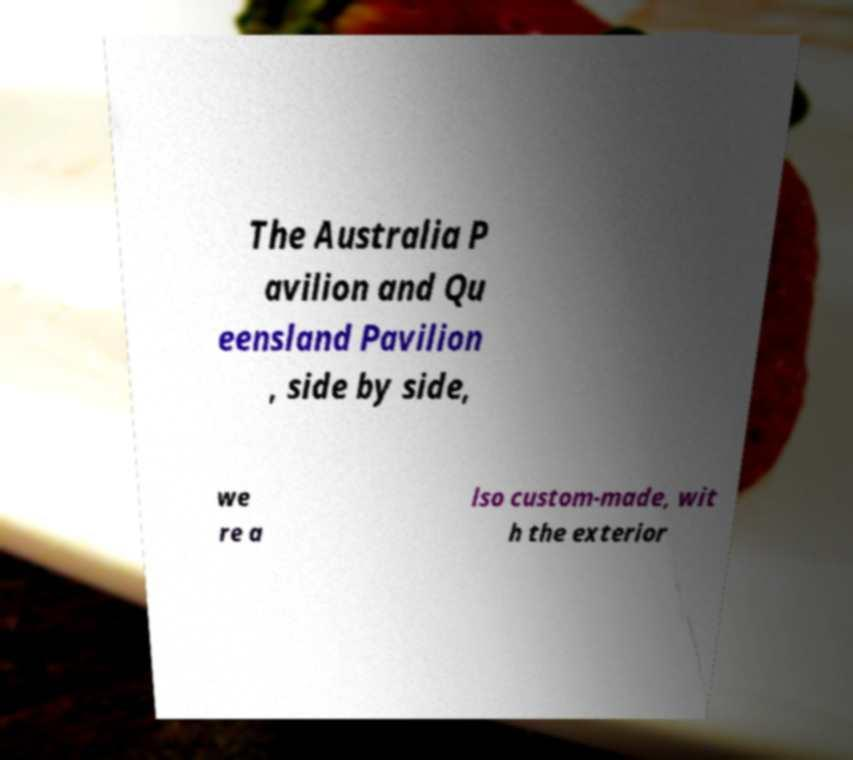Can you accurately transcribe the text from the provided image for me? The Australia P avilion and Qu eensland Pavilion , side by side, we re a lso custom-made, wit h the exterior 